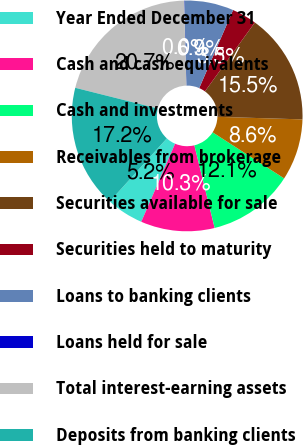Convert chart to OTSL. <chart><loc_0><loc_0><loc_500><loc_500><pie_chart><fcel>Year Ended December 31<fcel>Cash and cash equivalents<fcel>Cash and investments<fcel>Receivables from brokerage<fcel>Securities available for sale<fcel>Securities held to maturity<fcel>Loans to banking clients<fcel>Loans held for sale<fcel>Total interest-earning assets<fcel>Deposits from banking clients<nl><fcel>5.19%<fcel>10.34%<fcel>12.06%<fcel>8.63%<fcel>15.5%<fcel>3.47%<fcel>6.91%<fcel>0.03%<fcel>20.66%<fcel>17.22%<nl></chart> 